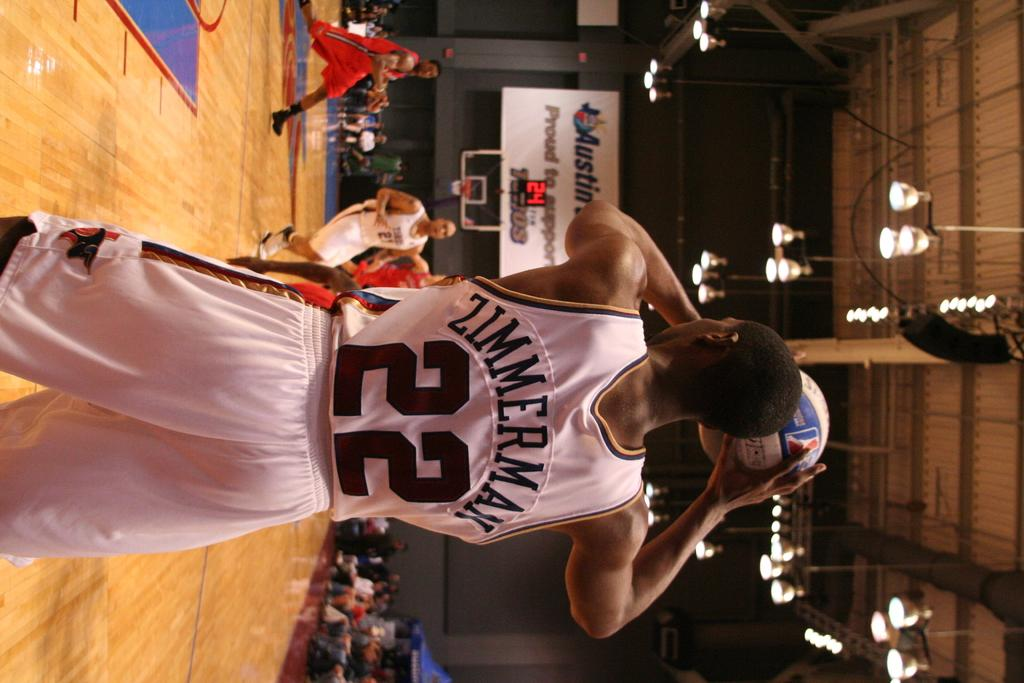<image>
Write a terse but informative summary of the picture. Basketball player named Zimmerman getting ready to inbound the ball. 